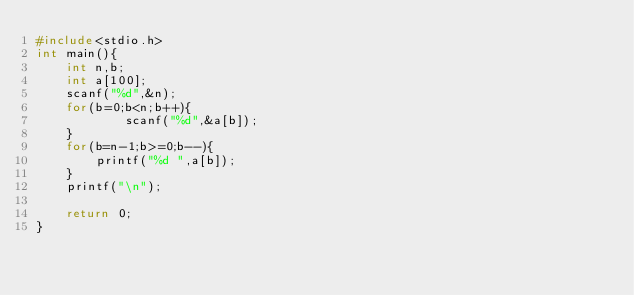<code> <loc_0><loc_0><loc_500><loc_500><_C_>#include<stdio.h>
int main(){
	int n,b;
	int a[100];
	scanf("%d",&n);
	for(b=0;b<n;b++){
			scanf("%d",&a[b]);
	}
	for(b=n-1;b>=0;b--){
		printf("%d ",a[b]);
	}
	printf("\n");
	
	return 0;
}</code> 